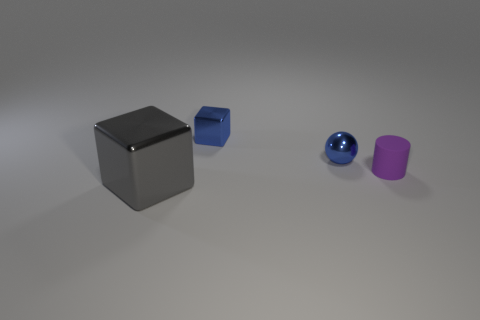Add 1 tiny purple matte cylinders. How many objects exist? 5 Subtract all spheres. How many objects are left? 3 Subtract all rubber cylinders. Subtract all gray metallic objects. How many objects are left? 2 Add 3 purple things. How many purple things are left? 4 Add 4 purple metallic balls. How many purple metallic balls exist? 4 Subtract 0 cyan cubes. How many objects are left? 4 